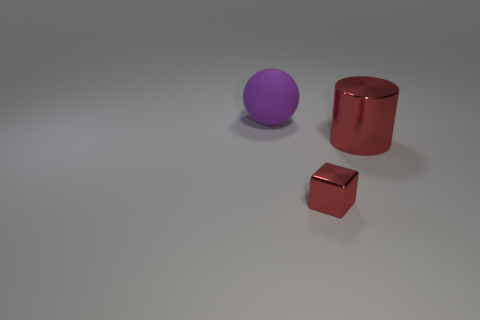Add 2 spheres. How many objects exist? 5 Subtract all blocks. How many objects are left? 2 Subtract all cylinders. Subtract all red blocks. How many objects are left? 1 Add 1 tiny red objects. How many tiny red objects are left? 2 Add 1 small cubes. How many small cubes exist? 2 Subtract 0 cyan blocks. How many objects are left? 3 